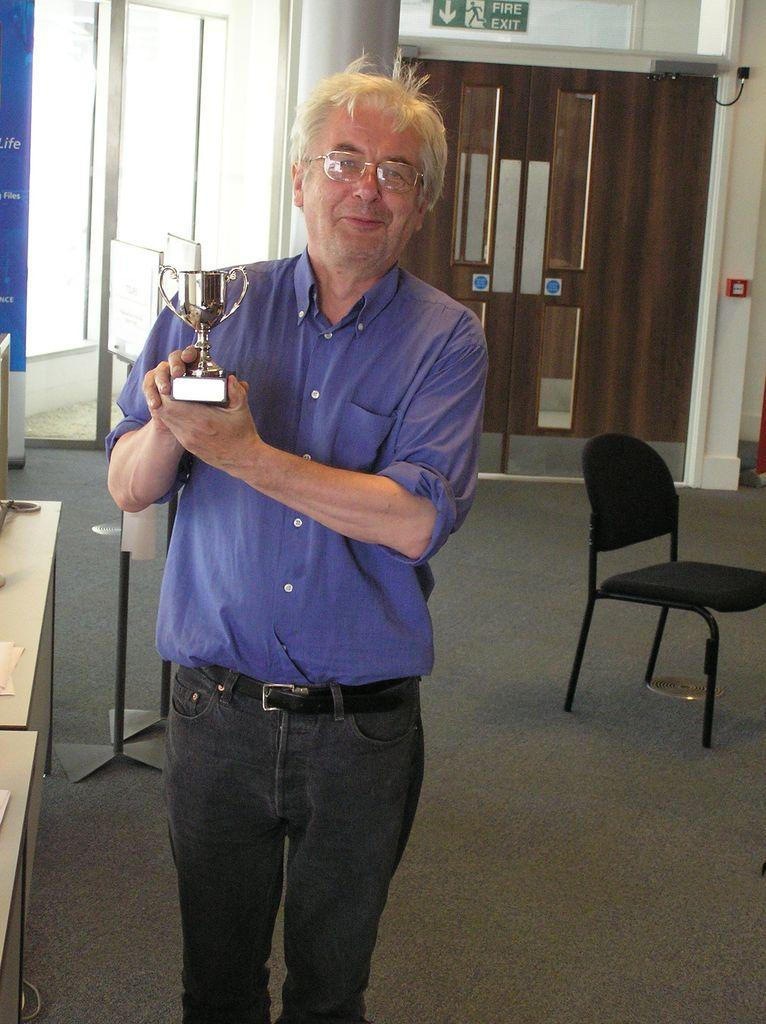What is the man in the image doing? The man is standing in the image and holding a trophy. What can be seen above the door in the image? There is a sign board above the door in the image. What type of furniture is present in the image? There is a chair and a table in the image. What type of suit is the coach wearing in the image? There is no coach or suit present in the image. 